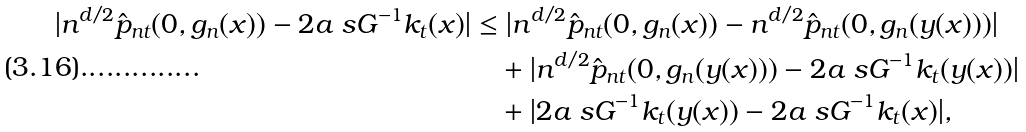<formula> <loc_0><loc_0><loc_500><loc_500>| n ^ { d / 2 } \hat { p } _ { n t } ( 0 , g _ { n } ( x ) ) - 2 a _ { \ } s G ^ { - 1 } k _ { t } ( x ) | & \leq | n ^ { d / 2 } \hat { p } _ { n t } ( 0 , g _ { n } ( x ) ) - n ^ { d / 2 } \hat { p } _ { n t } ( 0 , g _ { n } ( y ( x ) ) ) | \\ & \quad + | n ^ { d / 2 } \hat { p } _ { n t } ( 0 , g _ { n } ( y ( x ) ) ) - 2 a _ { \ } s G ^ { - 1 } k _ { t } ( y ( x ) ) | \\ & \quad + | 2 a _ { \ } s G ^ { - 1 } k _ { t } ( y ( x ) ) - 2 a _ { \ } s G ^ { - 1 } k _ { t } ( x ) | ,</formula> 